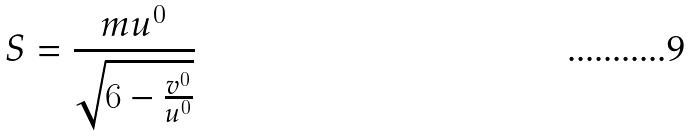Convert formula to latex. <formula><loc_0><loc_0><loc_500><loc_500>S = \frac { m u ^ { 0 } } { \sqrt { 6 - \frac { v ^ { 0 } } { u ^ { 0 } } } }</formula> 